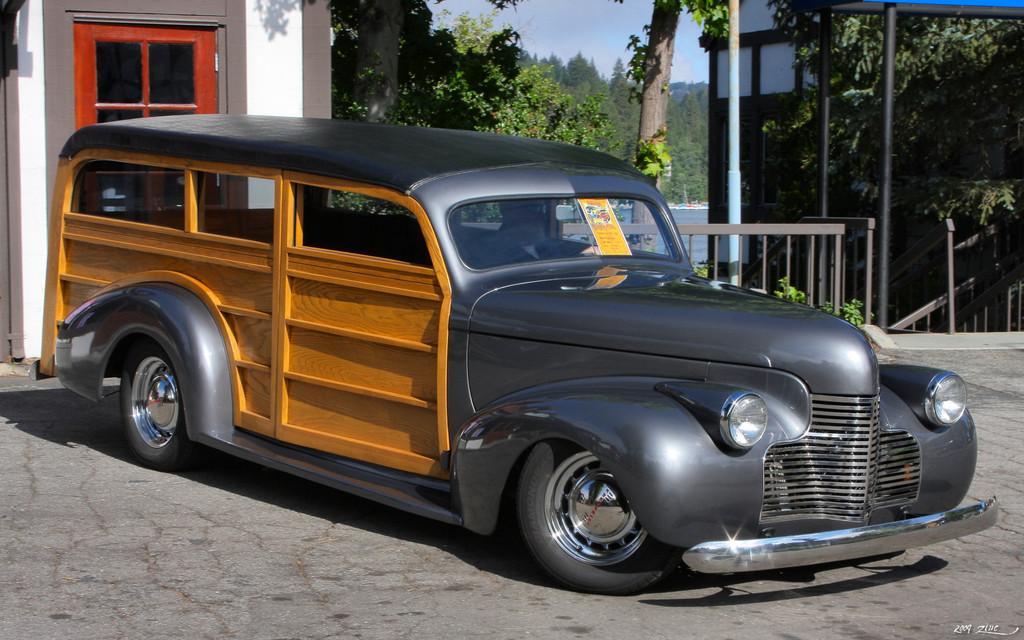Please provide a concise description of this image. In this image I can see the vehicle on the road. In the background I can see the railing, buildings and trees. I can also see the water, few more trees and the sky. 